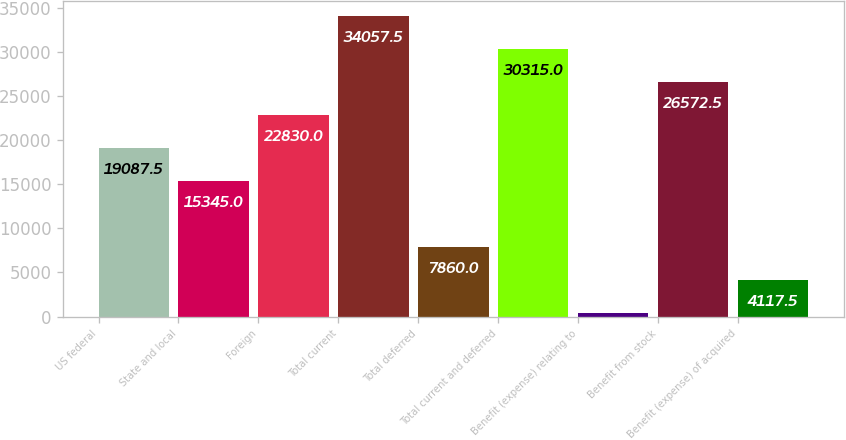Convert chart to OTSL. <chart><loc_0><loc_0><loc_500><loc_500><bar_chart><fcel>US federal<fcel>State and local<fcel>Foreign<fcel>Total current<fcel>Total deferred<fcel>Total current and deferred<fcel>Benefit (expense) relating to<fcel>Benefit from stock<fcel>Benefit (expense) of acquired<nl><fcel>19087.5<fcel>15345<fcel>22830<fcel>34057.5<fcel>7860<fcel>30315<fcel>375<fcel>26572.5<fcel>4117.5<nl></chart> 